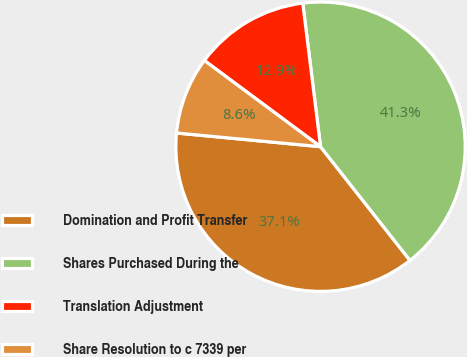Convert chart to OTSL. <chart><loc_0><loc_0><loc_500><loc_500><pie_chart><fcel>Domination and Profit Transfer<fcel>Shares Purchased During the<fcel>Translation Adjustment<fcel>Share Resolution to c 7339 per<nl><fcel>37.12%<fcel>41.35%<fcel>12.88%<fcel>8.65%<nl></chart> 